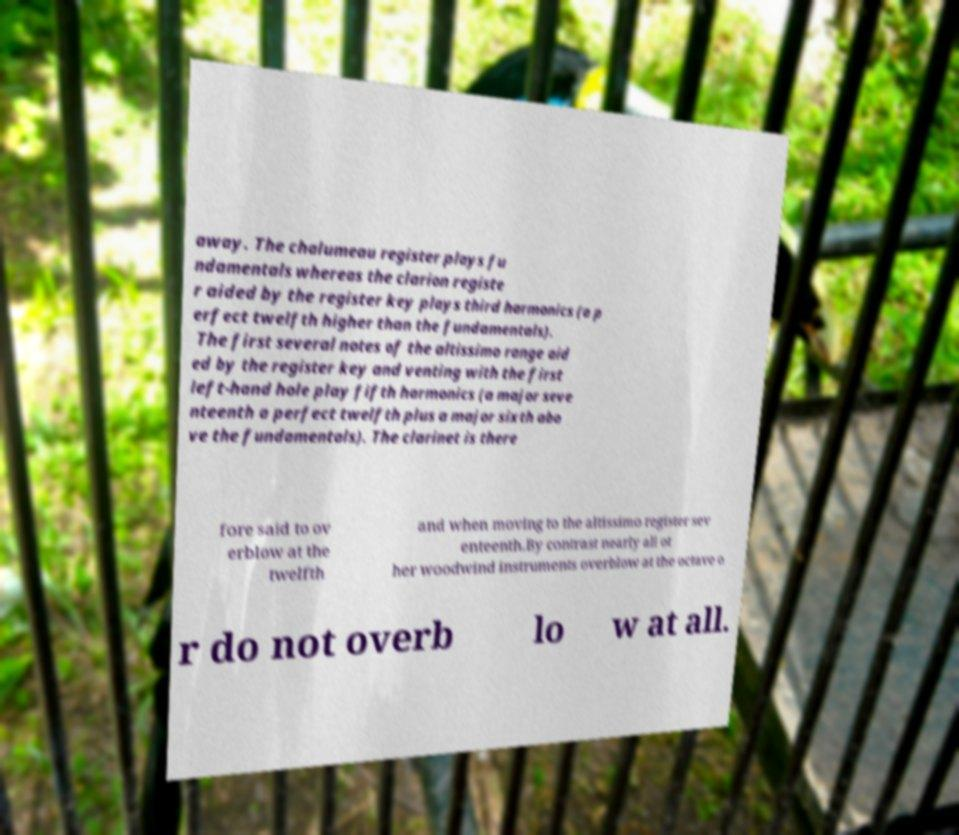Please identify and transcribe the text found in this image. away. The chalumeau register plays fu ndamentals whereas the clarion registe r aided by the register key plays third harmonics (a p erfect twelfth higher than the fundamentals). The first several notes of the altissimo range aid ed by the register key and venting with the first left-hand hole play fifth harmonics (a major seve nteenth a perfect twelfth plus a major sixth abo ve the fundamentals). The clarinet is there fore said to ov erblow at the twelfth and when moving to the altissimo register sev enteenth.By contrast nearly all ot her woodwind instruments overblow at the octave o r do not overb lo w at all. 